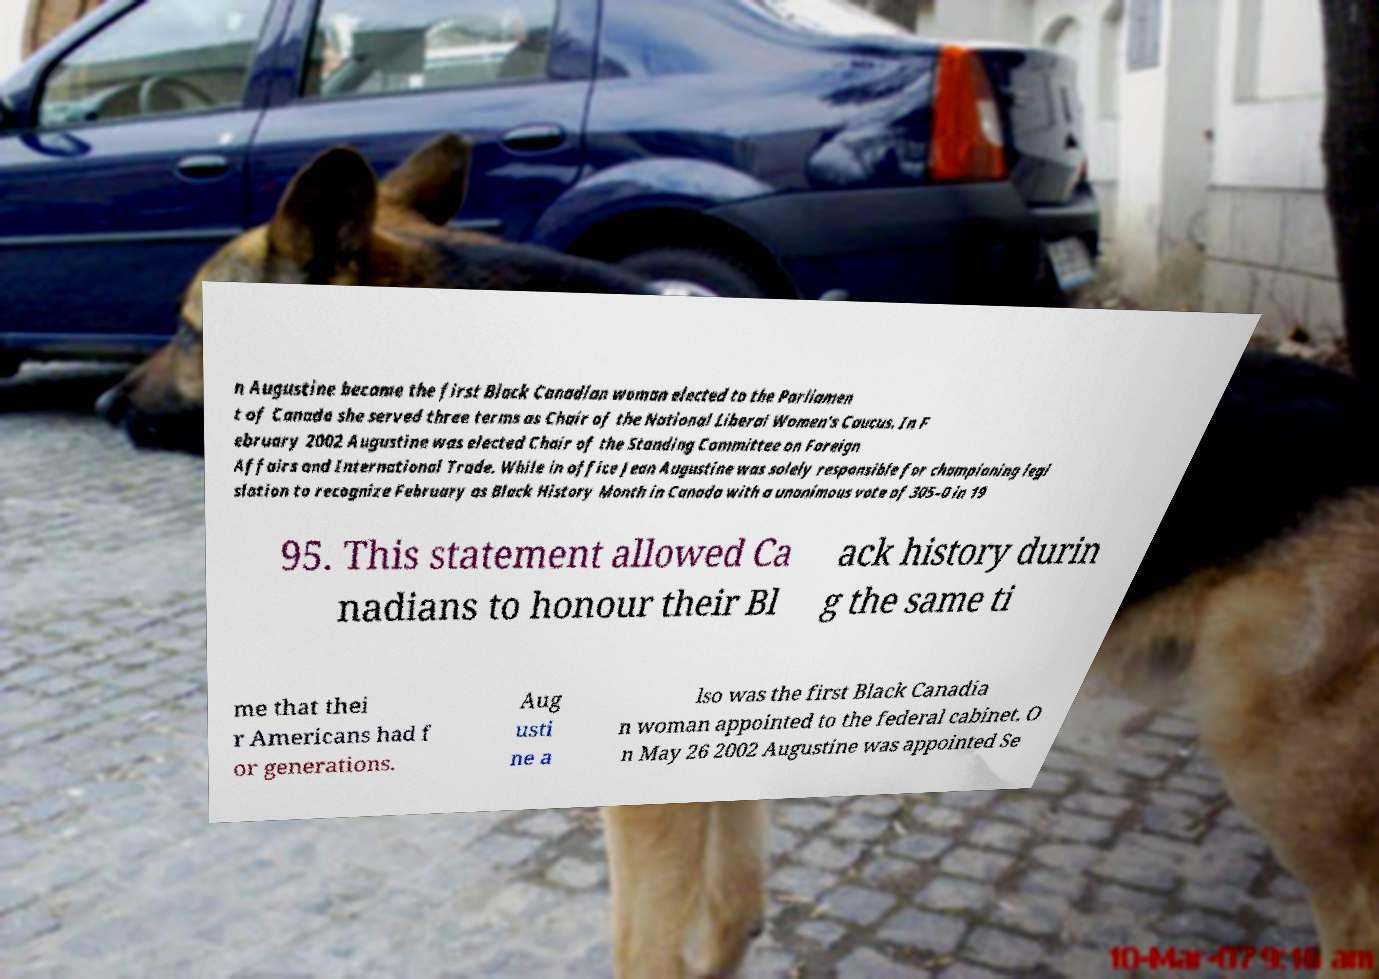Can you accurately transcribe the text from the provided image for me? n Augustine became the first Black Canadian woman elected to the Parliamen t of Canada she served three terms as Chair of the National Liberal Women's Caucus. In F ebruary 2002 Augustine was elected Chair of the Standing Committee on Foreign Affairs and International Trade. While in office Jean Augustine was solely responsible for championing legi slation to recognize February as Black History Month in Canada with a unanimous vote of 305–0 in 19 95. This statement allowed Ca nadians to honour their Bl ack history durin g the same ti me that thei r Americans had f or generations. Aug usti ne a lso was the first Black Canadia n woman appointed to the federal cabinet. O n May 26 2002 Augustine was appointed Se 